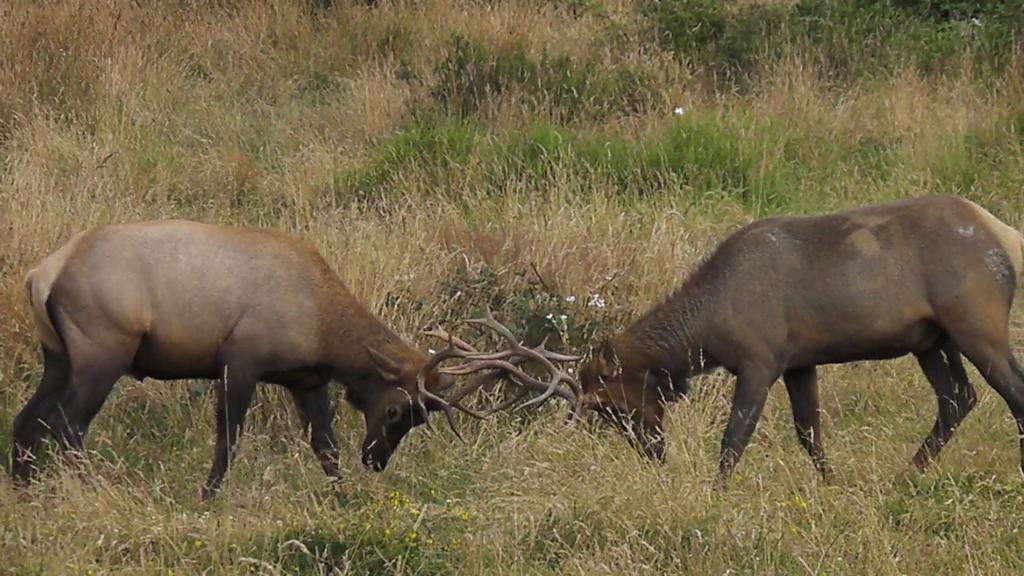Please provide a concise description of this image. In this image, we can see animals fighting and in the background, there is grass. 